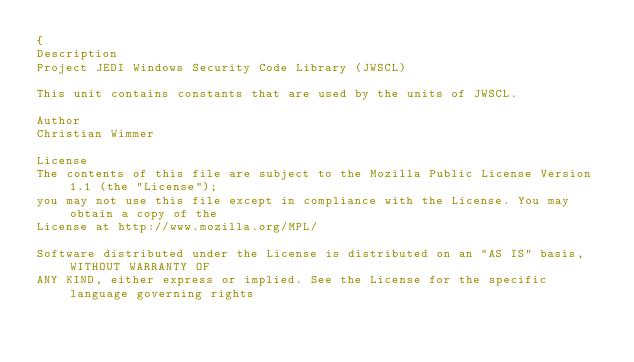<code> <loc_0><loc_0><loc_500><loc_500><_Pascal_>{
Description
Project JEDI Windows Security Code Library (JWSCL)

This unit contains constants that are used by the units of JWSCL.

Author
Christian Wimmer

License
The contents of this file are subject to the Mozilla Public License Version 1.1 (the "License");
you may not use this file except in compliance with the License. You may obtain a copy of the
License at http://www.mozilla.org/MPL/

Software distributed under the License is distributed on an "AS IS" basis, WITHOUT WARRANTY OF
ANY KIND, either express or implied. See the License for the specific language governing rights</code> 